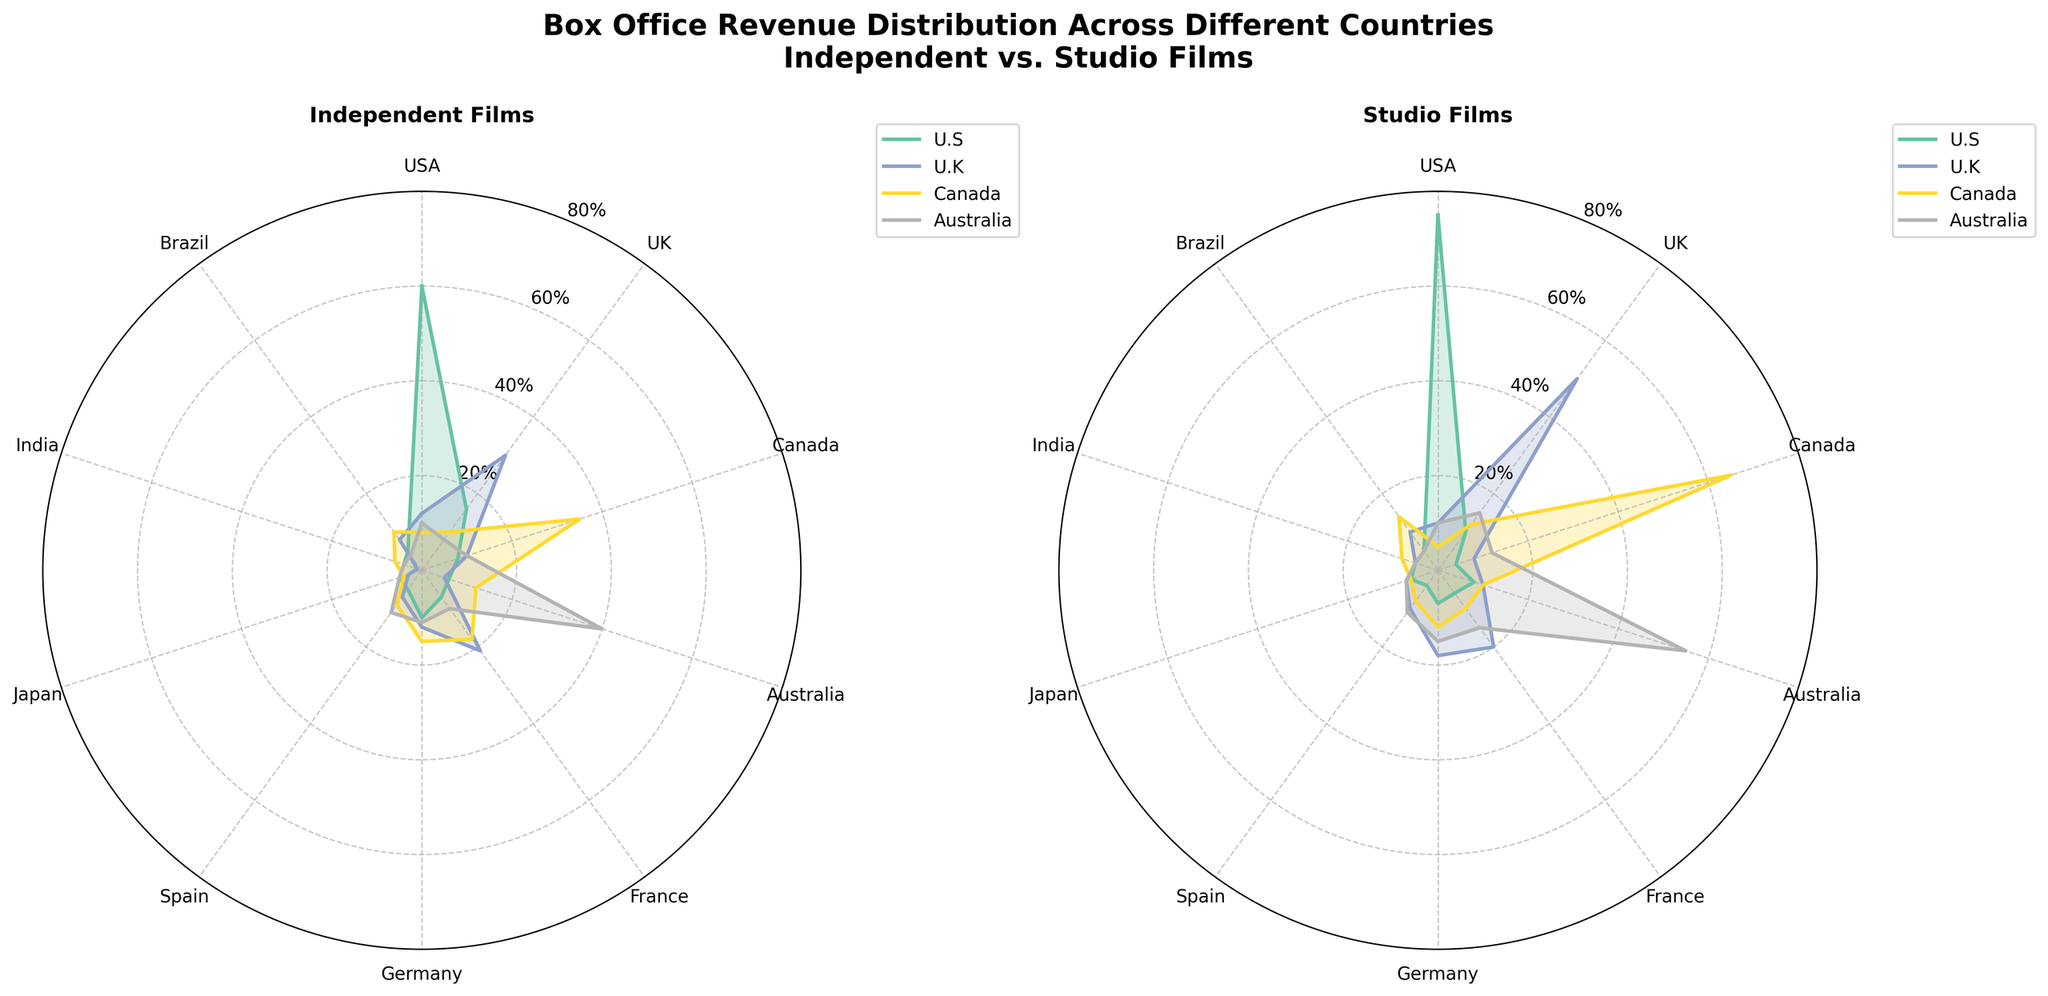What are the titles of the subplots? The titles are positioned above each subplot within the figure. One subplot is titled "Independent Films" and the other is titled "Studio Films"
Answer: Independent Films; Studio Films How many countries are represented in the radar charts? Count the number of countries listed around the perimeter of the radar charts. Both radar charts include the same countries.
Answer: 10 Which country has the highest box office revenue percentage for Independent U.S. films? Refer to the plot for Independent Films and find the country where the Independent U.S. line peaks the highest. In this case, "USA" has the highest value
Answer: USA In the Studio Films subplot, which country sees the highest revenue percentage from Studio Canada? Locate the Studio Canada dataset on the Studio Films subplot and identify the country associated with the highest value. "Canada" has the highest peak for Studio Canada
Answer: Canada What is the average box office revenue percentage for Independent U.K. films across all countries? Add up all the Independent U.K. values and then divide by the number of countries to find the average. Calculate (12 + 30 + 10 + 5 + 21 + 12 + 7 + 3 + 1 + 8) / 10
Answer: 10.9 Which country has the lowest box office revenue percentage for Studio Australia? Find the country with the smallest radial value on the Studio Films subplot for Studio Australia. India has the lowest figure at 5%
Answer: India Compare the revenue percentages of Studio U.K. and Independent U.K. films in Germany. Which is higher? Look at the values for Germany in both the Studio Films and Independent Films subplots. Studio U.K. shows 18%, whereas Independent U.K. shows 12%. Studio U.K. is higher
Answer: Studio U.K Does Japan have a higher revenue percentage for Independent U.K. films or Studio U.K. films? Compare the individual percentages for Japan on both subplots. Independent U.K. is 3% and Studio U.K. is 7%. Studio U.K. percentage is higher
Answer: Studio U.K What is the difference in revenue percentages between Independent U.S. films and Studio U.S. films in France? Subtract the percentage of Studio U.S. from Independent U.S. in France. Calculate 7% - 6%
Answer: 1% In the Independent Films subplot, how many countries have a revenue percentage of 10% or higher for Independent Canada? Identify the countries where Independent Canada values are 10% or higher by referencing the subplot for Independent Films. The countries include Canada, Australia, France, and Germany
Answer: 4 